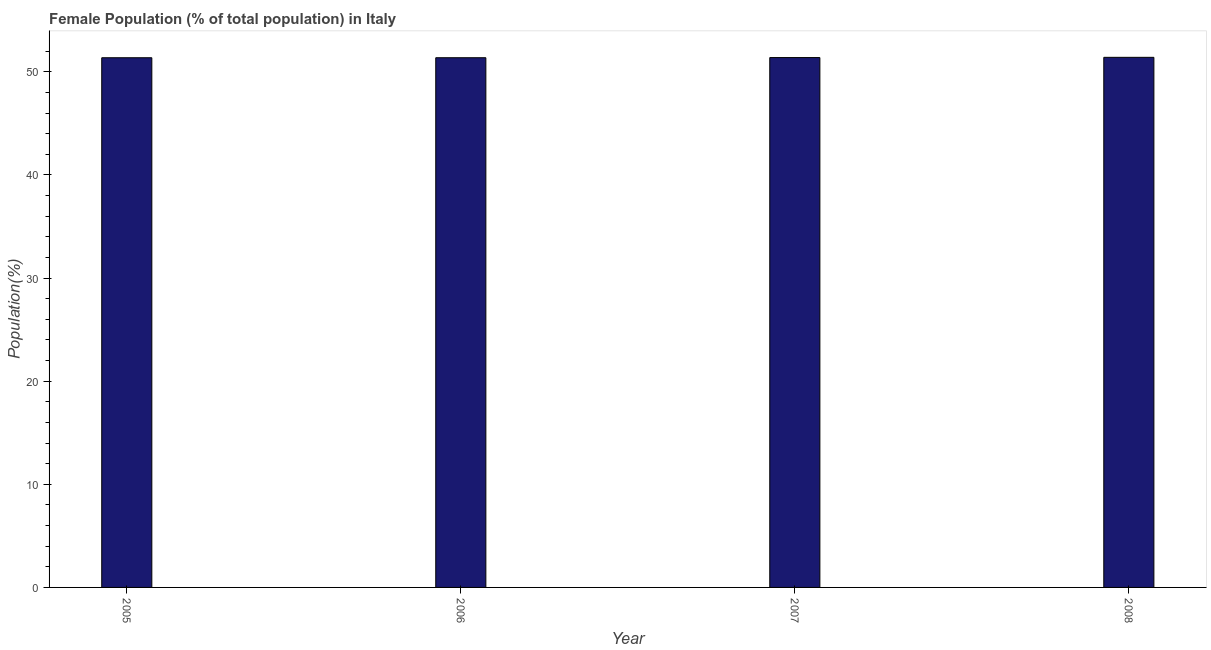Does the graph contain any zero values?
Your response must be concise. No. Does the graph contain grids?
Your response must be concise. No. What is the title of the graph?
Your answer should be compact. Female Population (% of total population) in Italy. What is the label or title of the Y-axis?
Provide a short and direct response. Population(%). What is the female population in 2008?
Give a very brief answer. 51.41. Across all years, what is the maximum female population?
Your response must be concise. 51.41. Across all years, what is the minimum female population?
Make the answer very short. 51.37. In which year was the female population maximum?
Your response must be concise. 2008. What is the sum of the female population?
Offer a terse response. 205.52. What is the difference between the female population in 2006 and 2008?
Provide a short and direct response. -0.04. What is the average female population per year?
Your answer should be compact. 51.38. What is the median female population?
Provide a short and direct response. 51.38. In how many years, is the female population greater than 6 %?
Offer a terse response. 4. Is the female population in 2006 less than that in 2008?
Give a very brief answer. Yes. Is the difference between the female population in 2006 and 2007 greater than the difference between any two years?
Provide a short and direct response. No. What is the difference between the highest and the second highest female population?
Offer a terse response. 0.02. Is the sum of the female population in 2007 and 2008 greater than the maximum female population across all years?
Your answer should be compact. Yes. How many years are there in the graph?
Your response must be concise. 4. Are the values on the major ticks of Y-axis written in scientific E-notation?
Offer a terse response. No. What is the Population(%) of 2005?
Provide a succinct answer. 51.37. What is the Population(%) in 2006?
Make the answer very short. 51.37. What is the Population(%) of 2007?
Offer a terse response. 51.38. What is the Population(%) of 2008?
Make the answer very short. 51.41. What is the difference between the Population(%) in 2005 and 2006?
Your answer should be very brief. -0. What is the difference between the Population(%) in 2005 and 2007?
Provide a short and direct response. -0.02. What is the difference between the Population(%) in 2005 and 2008?
Offer a terse response. -0.04. What is the difference between the Population(%) in 2006 and 2007?
Your answer should be compact. -0.02. What is the difference between the Population(%) in 2006 and 2008?
Keep it short and to the point. -0.04. What is the difference between the Population(%) in 2007 and 2008?
Your answer should be compact. -0.02. What is the ratio of the Population(%) in 2005 to that in 2006?
Your answer should be compact. 1. What is the ratio of the Population(%) in 2006 to that in 2007?
Offer a terse response. 1. What is the ratio of the Population(%) in 2007 to that in 2008?
Ensure brevity in your answer.  1. 